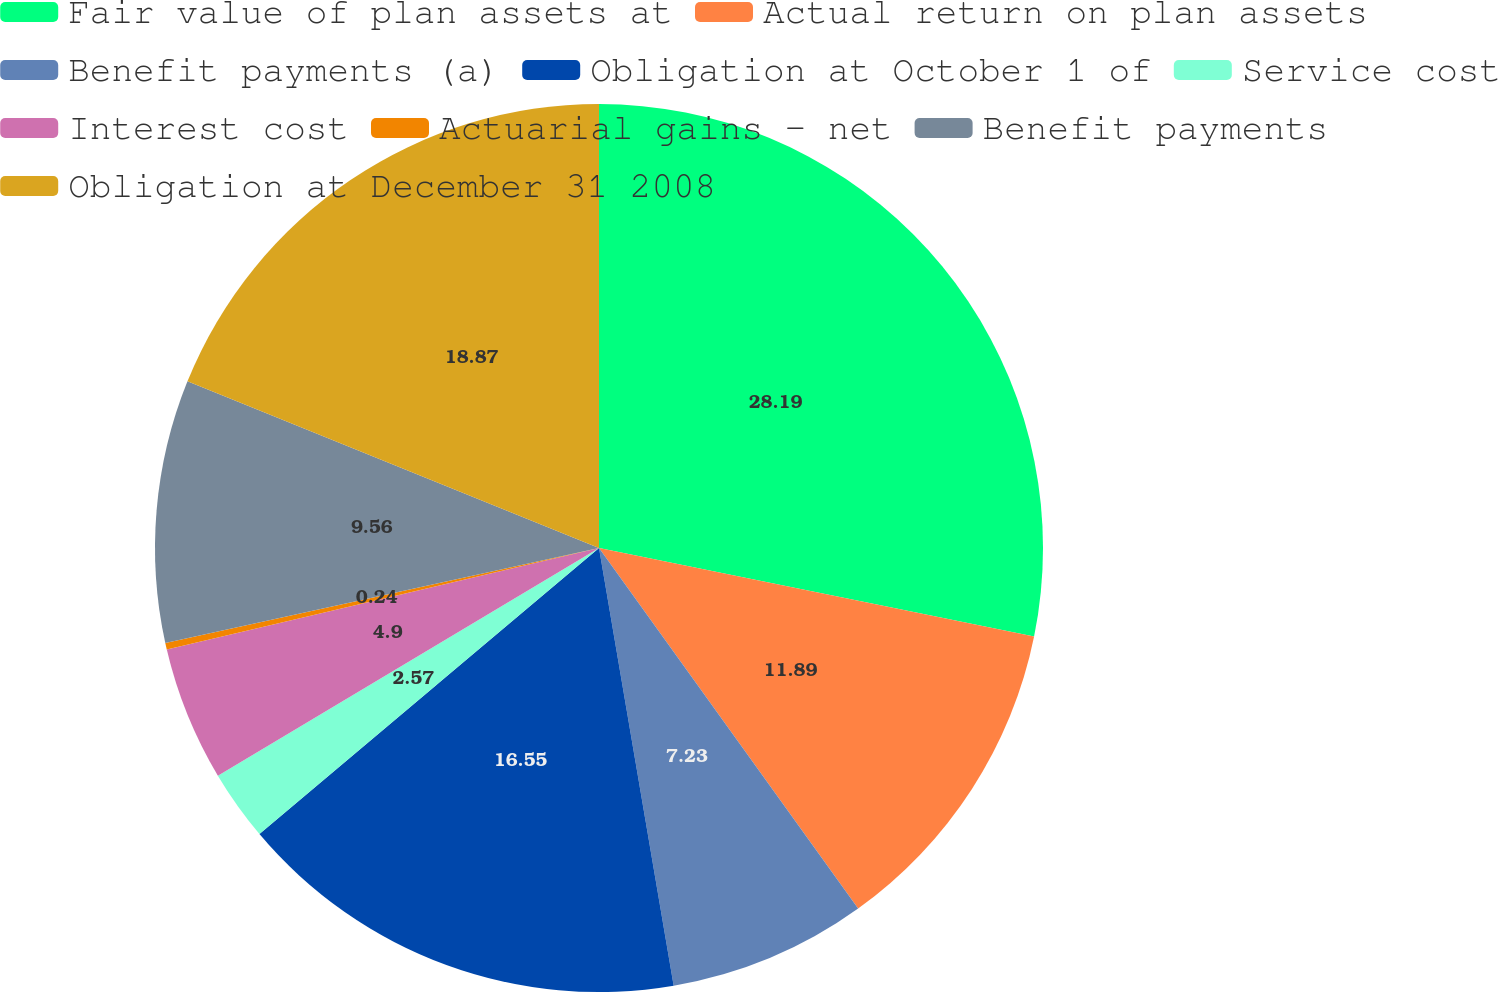<chart> <loc_0><loc_0><loc_500><loc_500><pie_chart><fcel>Fair value of plan assets at<fcel>Actual return on plan assets<fcel>Benefit payments (a)<fcel>Obligation at October 1 of<fcel>Service cost<fcel>Interest cost<fcel>Actuarial gains - net<fcel>Benefit payments<fcel>Obligation at December 31 2008<nl><fcel>28.2%<fcel>11.89%<fcel>7.23%<fcel>16.55%<fcel>2.57%<fcel>4.9%<fcel>0.24%<fcel>9.56%<fcel>18.88%<nl></chart> 